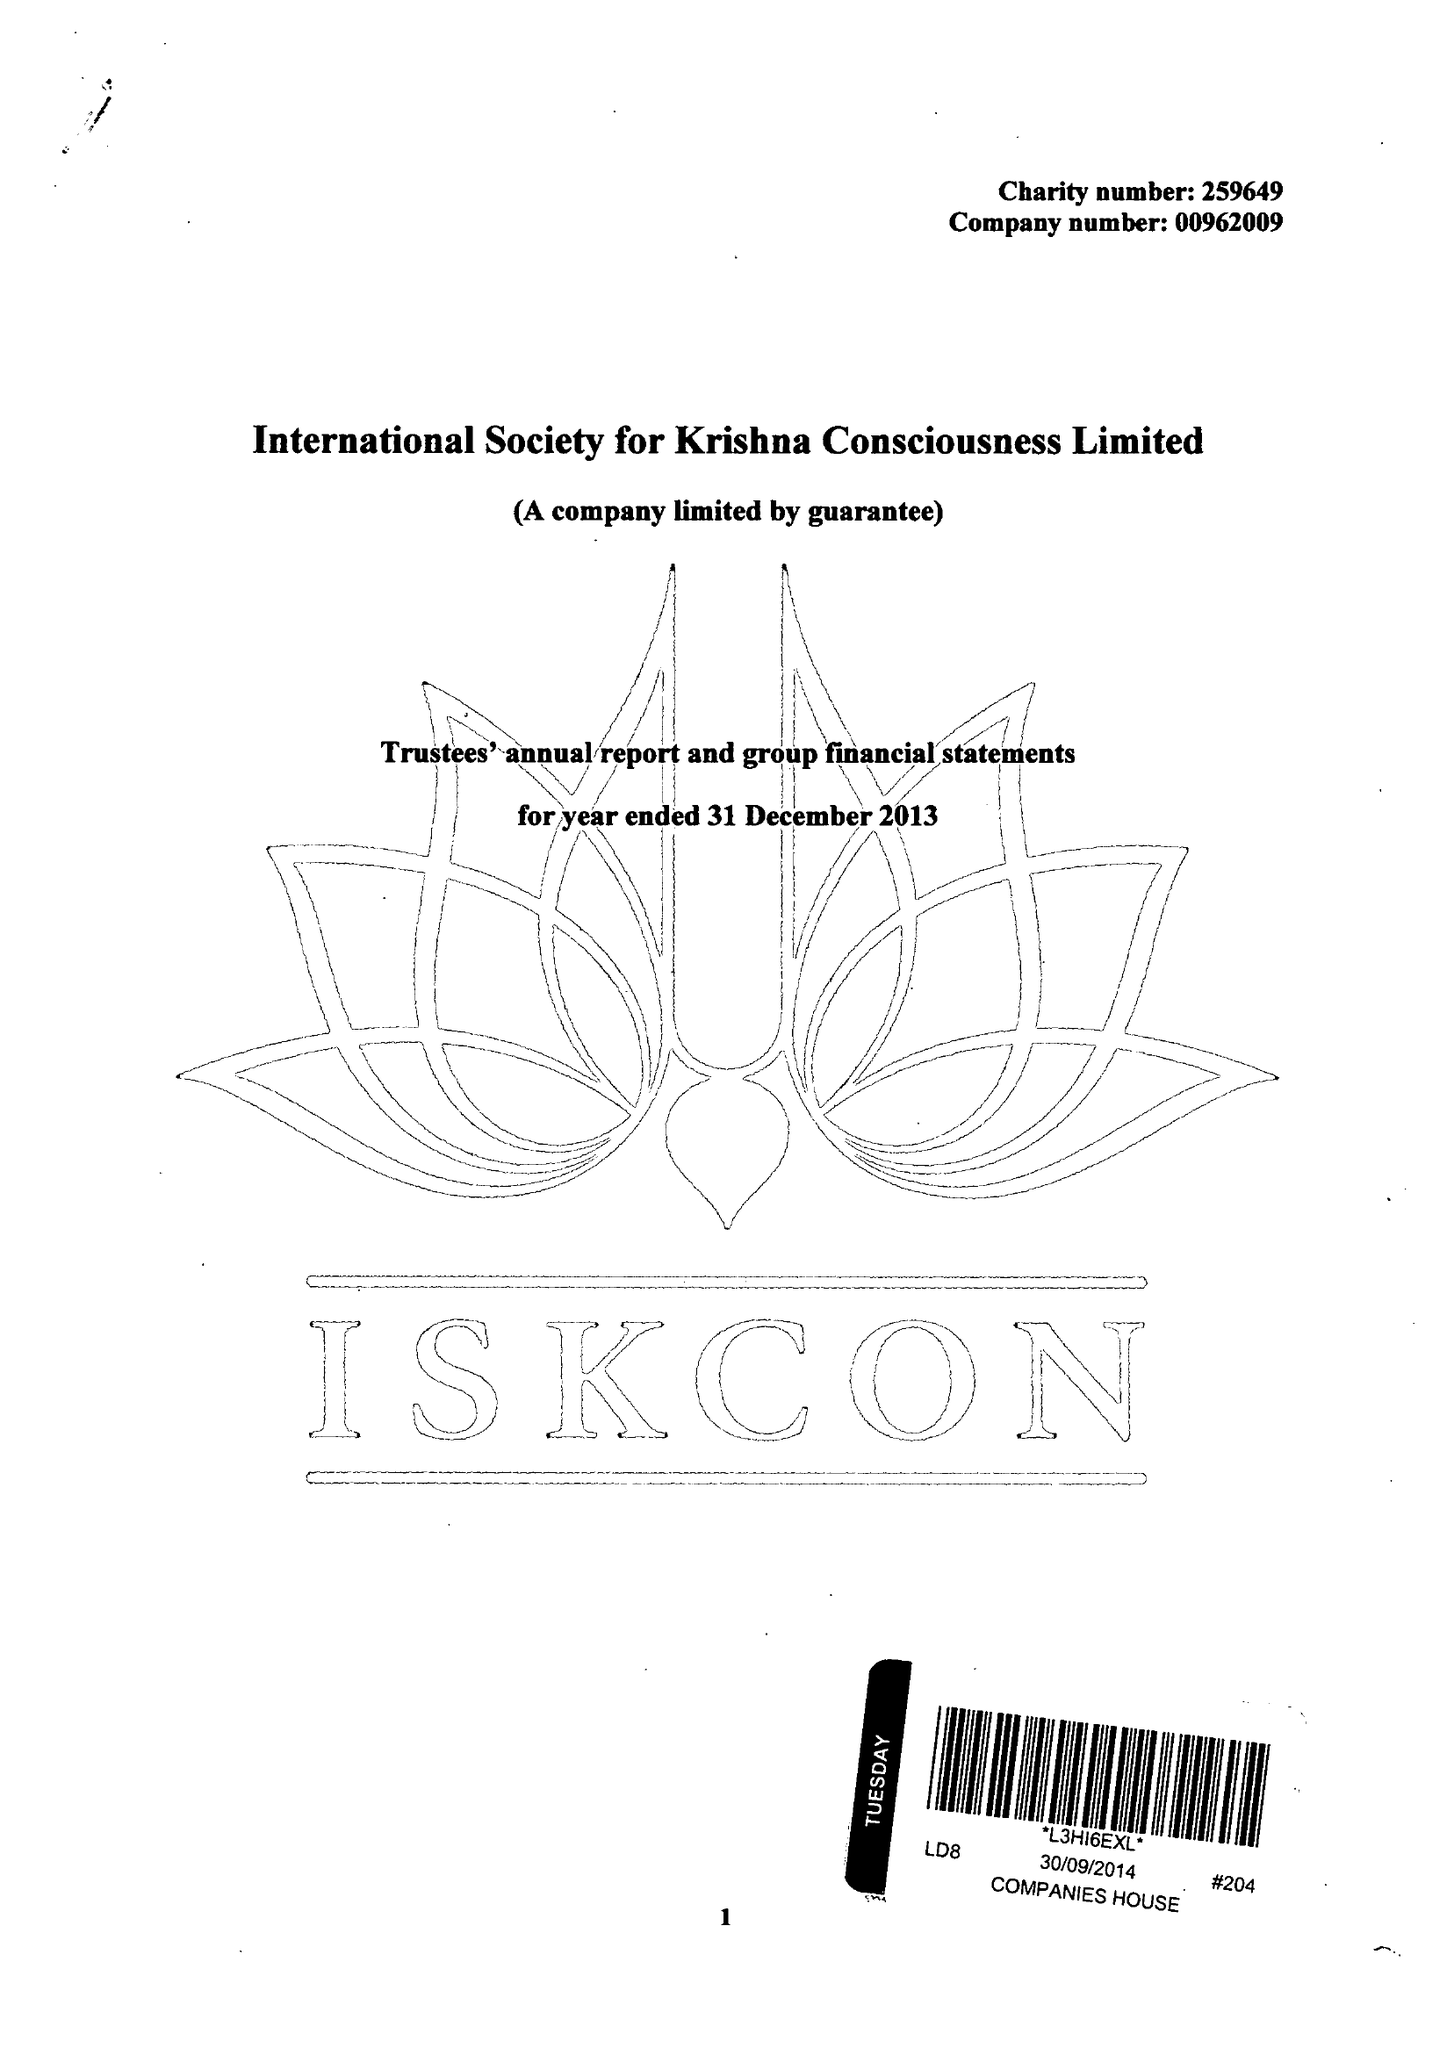What is the value for the spending_annually_in_british_pounds?
Answer the question using a single word or phrase. 5922881.00 